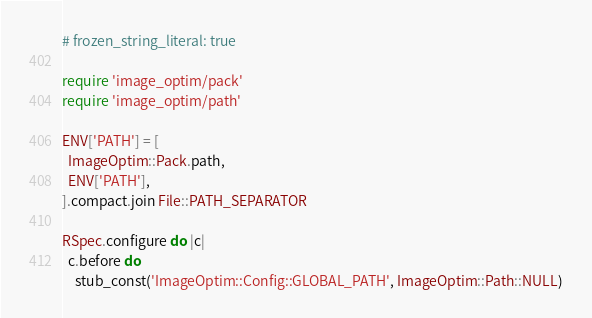<code> <loc_0><loc_0><loc_500><loc_500><_Ruby_># frozen_string_literal: true

require 'image_optim/pack'
require 'image_optim/path'

ENV['PATH'] = [
  ImageOptim::Pack.path,
  ENV['PATH'],
].compact.join File::PATH_SEPARATOR

RSpec.configure do |c|
  c.before do
    stub_const('ImageOptim::Config::GLOBAL_PATH', ImageOptim::Path::NULL)</code> 